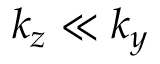Convert formula to latex. <formula><loc_0><loc_0><loc_500><loc_500>k _ { z } \ll k _ { y }</formula> 